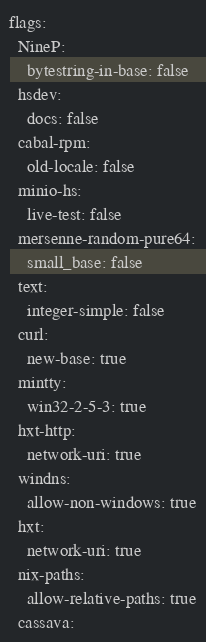<code> <loc_0><loc_0><loc_500><loc_500><_YAML_>flags:
  NineP:
    bytestring-in-base: false
  hsdev:
    docs: false
  cabal-rpm:
    old-locale: false
  minio-hs:
    live-test: false
  mersenne-random-pure64:
    small_base: false
  text:
    integer-simple: false
  curl:
    new-base: true
  mintty:
    win32-2-5-3: true
  hxt-http:
    network-uri: true
  windns:
    allow-non-windows: true
  hxt:
    network-uri: true
  nix-paths:
    allow-relative-paths: true
  cassava:</code> 